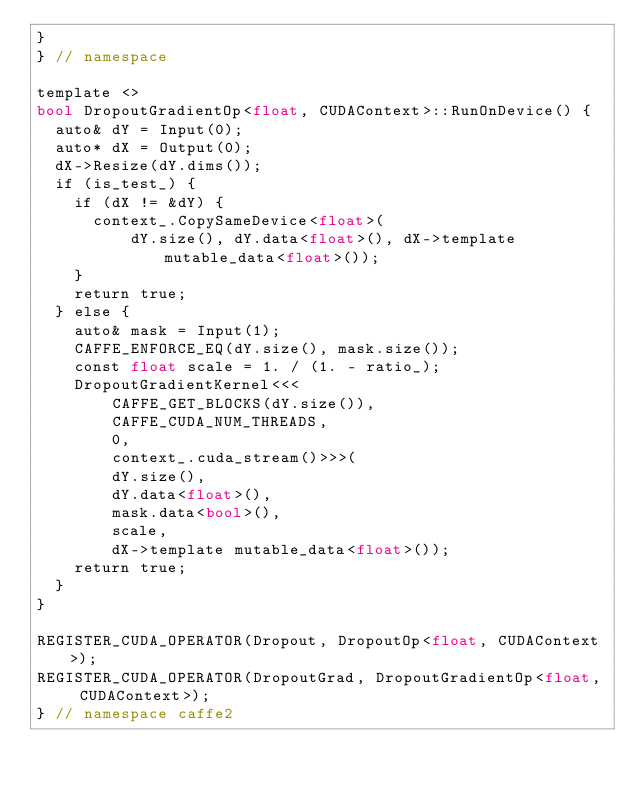Convert code to text. <code><loc_0><loc_0><loc_500><loc_500><_Cuda_>}
} // namespace

template <>
bool DropoutGradientOp<float, CUDAContext>::RunOnDevice() {
  auto& dY = Input(0);
  auto* dX = Output(0);
  dX->Resize(dY.dims());
  if (is_test_) {
    if (dX != &dY) {
      context_.CopySameDevice<float>(
          dY.size(), dY.data<float>(), dX->template mutable_data<float>());
    }
    return true;
  } else {
    auto& mask = Input(1);
    CAFFE_ENFORCE_EQ(dY.size(), mask.size());
    const float scale = 1. / (1. - ratio_);
    DropoutGradientKernel<<<
        CAFFE_GET_BLOCKS(dY.size()),
        CAFFE_CUDA_NUM_THREADS,
        0,
        context_.cuda_stream()>>>(
        dY.size(),
        dY.data<float>(),
        mask.data<bool>(),
        scale,
        dX->template mutable_data<float>());
    return true;
  }
}

REGISTER_CUDA_OPERATOR(Dropout, DropoutOp<float, CUDAContext>);
REGISTER_CUDA_OPERATOR(DropoutGrad, DropoutGradientOp<float, CUDAContext>);
} // namespace caffe2
</code> 